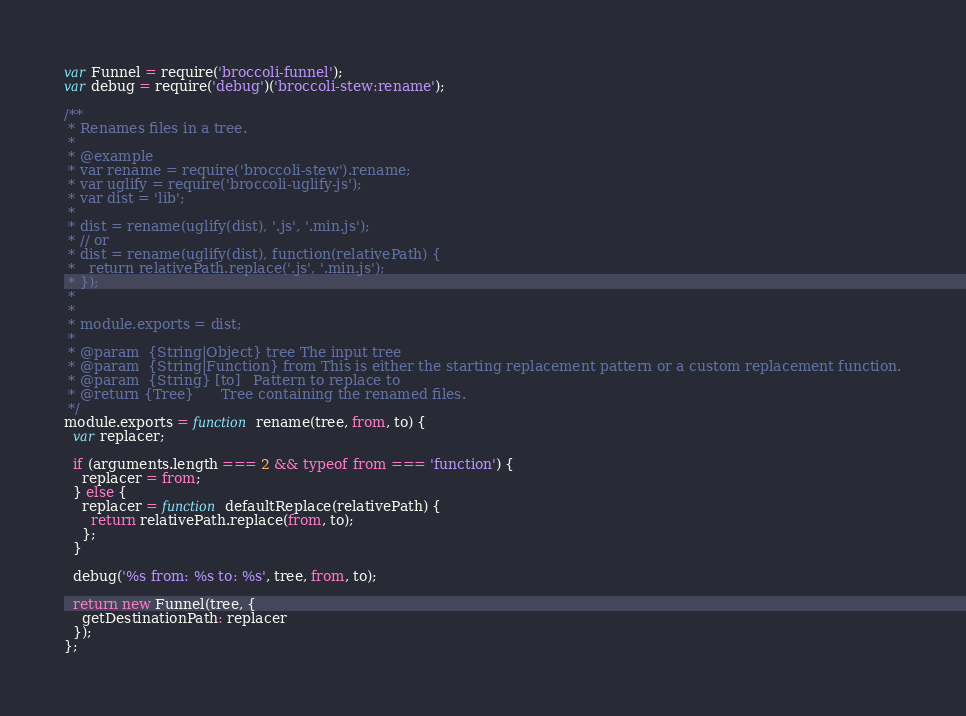Convert code to text. <code><loc_0><loc_0><loc_500><loc_500><_JavaScript_>var Funnel = require('broccoli-funnel');
var debug = require('debug')('broccoli-stew:rename');

/**
 * Renames files in a tree.
 *
 * @example
 * var rename = require('broccoli-stew').rename;
 * var uglify = require('broccoli-uglify-js');
 * var dist = 'lib';
 *
 * dist = rename(uglify(dist), '.js', '.min.js');
 * // or
 * dist = rename(uglify(dist), function(relativePath) {
 *   return relativePath.replace('.js', '.min.js');
 * });
 *
 *
 * module.exports = dist;
 *
 * @param  {String|Object} tree The input tree
 * @param  {String|Function} from This is either the starting replacement pattern or a custom replacement function.
 * @param  {String} [to]   Pattern to replace to
 * @return {Tree}      Tree containing the renamed files.
 */
module.exports = function rename(tree, from, to) {
  var replacer;

  if (arguments.length === 2 && typeof from === 'function') {
    replacer = from;
  } else {
    replacer = function defaultReplace(relativePath) {
      return relativePath.replace(from, to);
    };
  }

  debug('%s from: %s to: %s', tree, from, to);

  return new Funnel(tree, {
    getDestinationPath: replacer
  });
};
</code> 